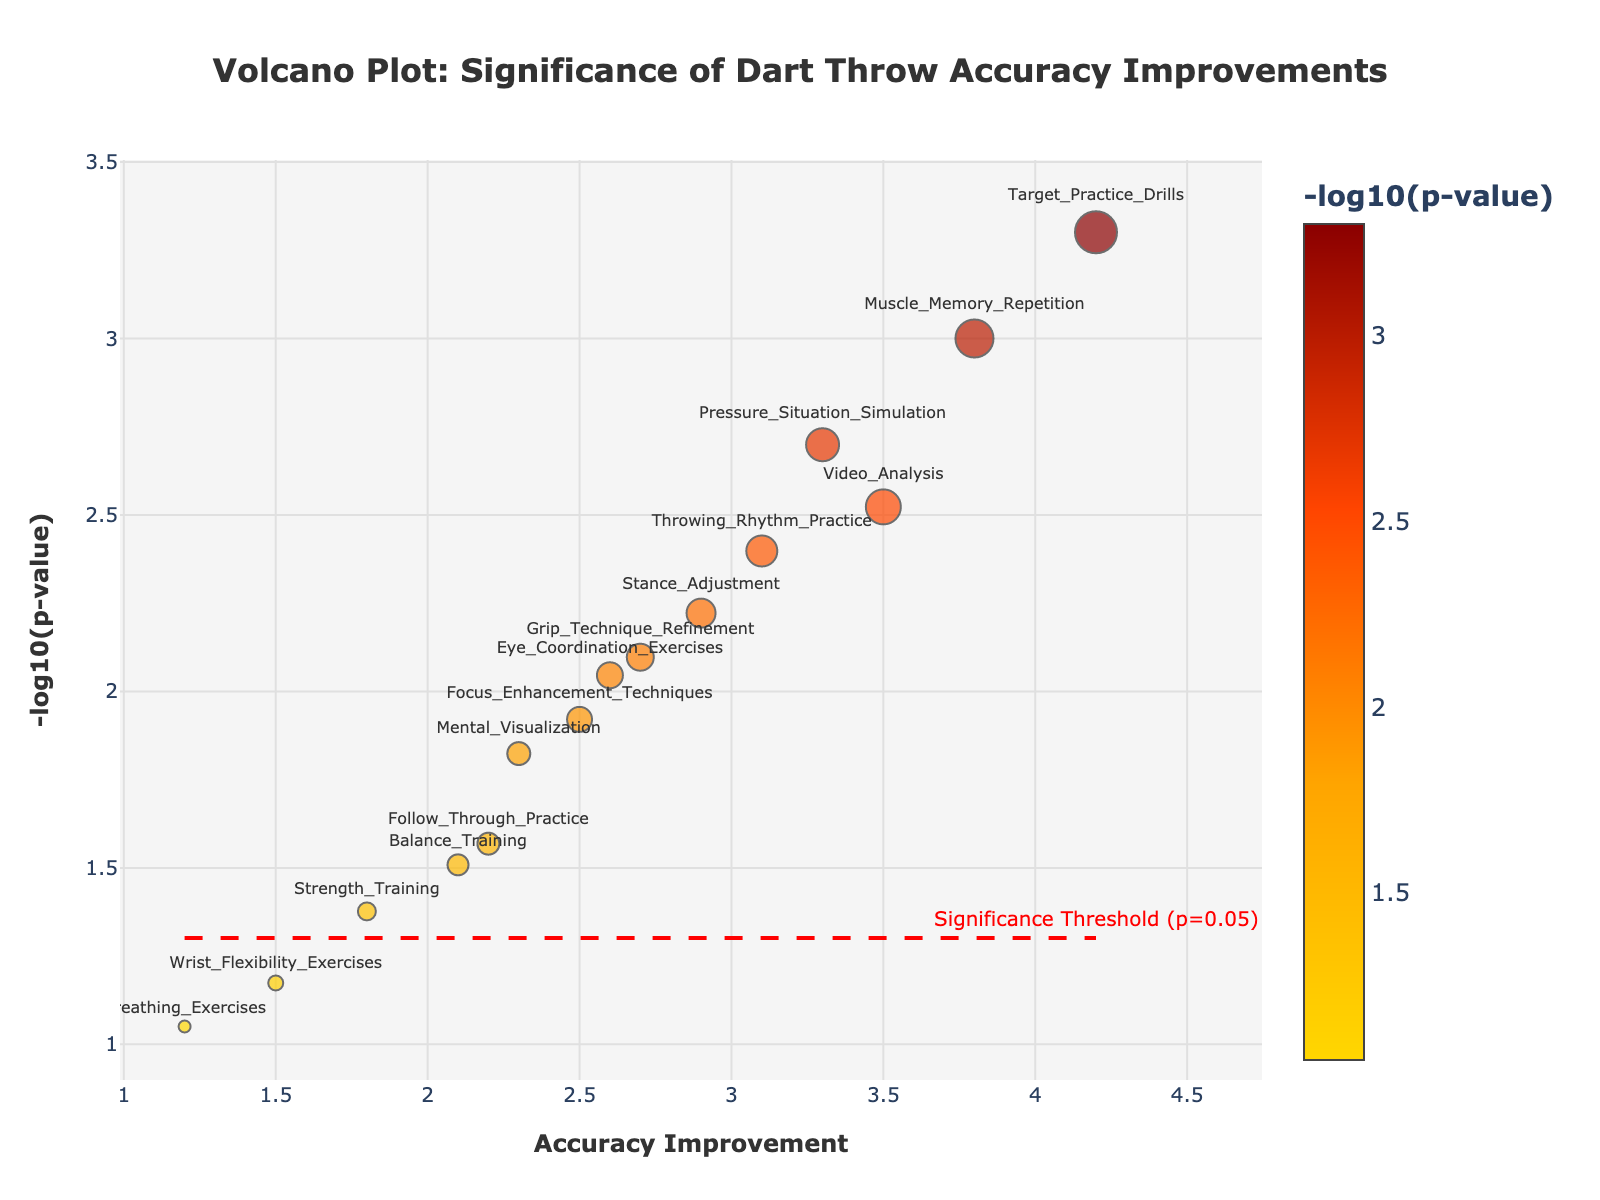What's the title of the plot? The title is usually displayed at the top of the plot and provides a summary of what the plot represents. In this case, it indicates the context of the data.
Answer: Volcano Plot: Significance of Dart Throw Accuracy Improvements What do the x-axis and y-axis represent? The x-axis represents 'Accuracy Improvement' which measures the improvement in dart throw accuracy by different training methods. The y-axis represents '-log10(p-value)', which shows the significance of the accuracy improvements on a logarithmic scale.
Answer: x-axis: Accuracy Improvement, y-axis: -log10(p-value) How many training methods show a statistically significant improvement (p < 0.05)? A statistically significant improvement is indicated by points above the red significance threshold line at -log10(p-value) = 1.3 (since p=0.05 corresponds to -log10(0.05) ≈ 1.3). Count the number of data points above this line.
Answer: 12 Which training method has the highest accuracy improvement? The highest accuracy improvement corresponds to the point farthest to the right on the x-axis. In this case, it’s easy to identify from the plot.
Answer: Target Practice Drills Which training method has the lowest p-value, and what does that imply? The lowest p-value is indicated by the highest -log10(p-value). This means finding the point that is highest on the y-axis.
Answer: Target Practice Drills, implying it has the most statistically significant improvement Compare 'Video Analysis' and 'Wrist Flexibility Exercises'. Which has a greater accuracy improvement and which is more statistically significant? Compare the x-values for accuracy improvement and y-values for -log10(p-value) between the two methods. 'Video Analysis' has higher values for both accuracy improvement and significance.
Answer: Video Analysis for both What is the -log10(p-value) threshold for significance, and why is it important? The threshold for significance is shown by a horizontal red dashed line at y = -log10(0.05) ≈ 1.3. This helps quickly identify which training methods are statistically significant.
Answer: -log10(0.05) ≈ 1.3; it differentiates significant improvements Which training methods fall below the significance threshold? Points that are below the red significance threshold line (y = 1.3) are not statistically significant. Identify those points from the plot.
Answer: Breathing Exercises and Wrist Flexibility Exercises How does 'Pressure Situation Simulation' compare with the significance threshold? Assess the position of 'Pressure Situation Simulation' in relation to the red dashed line at y = 1.3. It is just above this line, indicating statistical significance.
Answer: Just above the threshold, so significant What color represents the greatest statistical significance? The color scale indicates significance, with darker or brighter colors representing higher -log10(p-values). Identify this color based on the plot's color information.
Answer: Dark red 